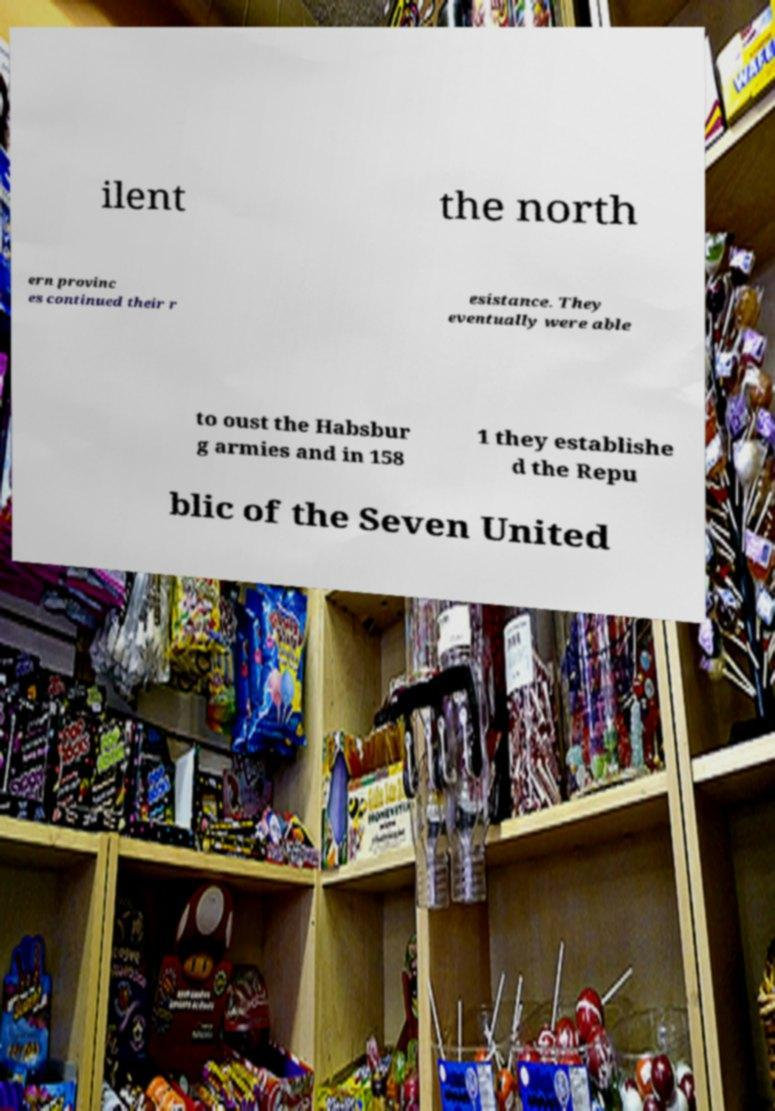There's text embedded in this image that I need extracted. Can you transcribe it verbatim? ilent the north ern provinc es continued their r esistance. They eventually were able to oust the Habsbur g armies and in 158 1 they establishe d the Repu blic of the Seven United 